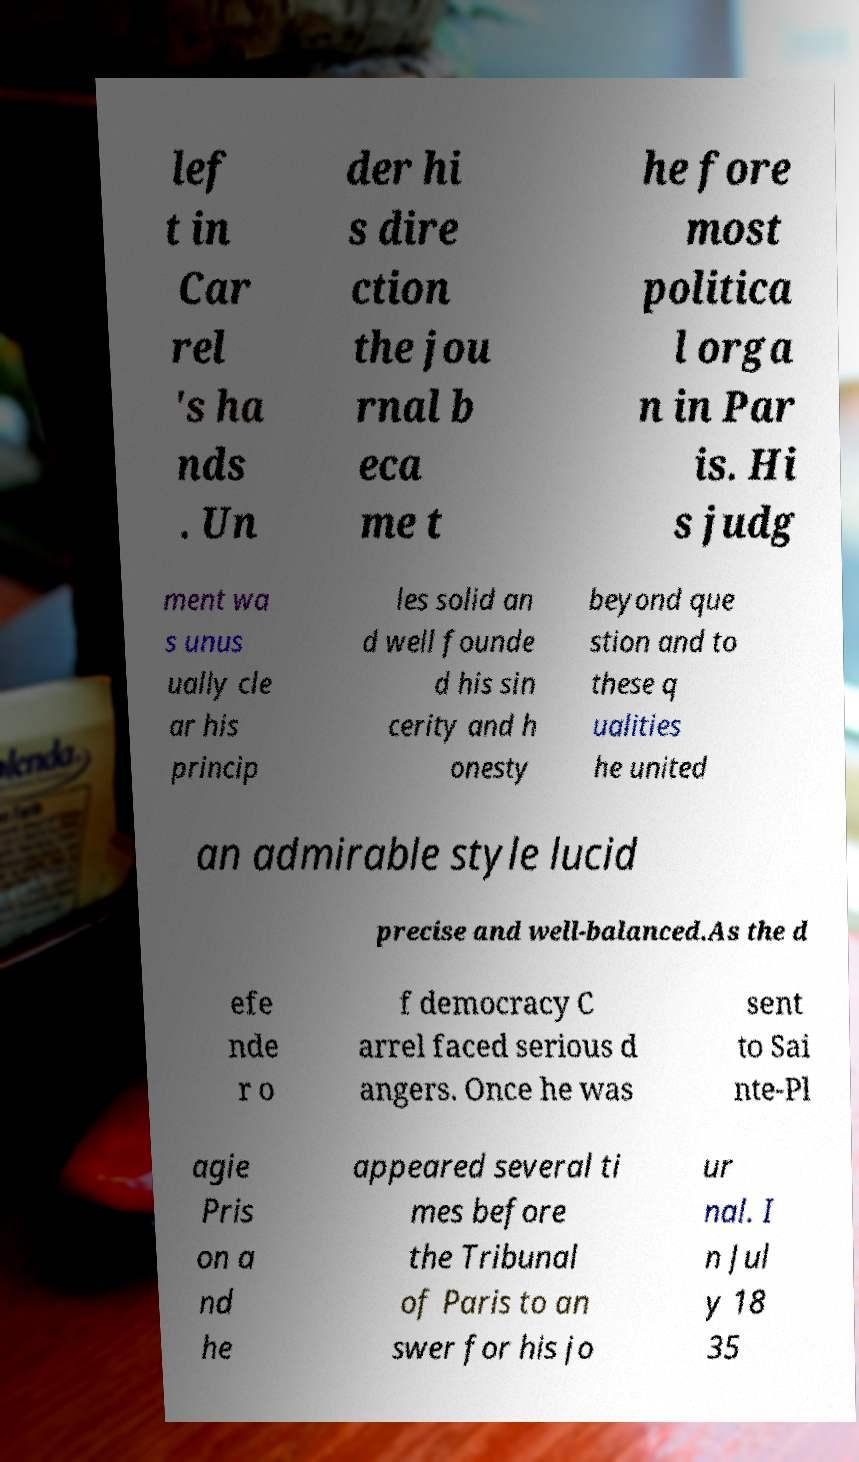Please read and relay the text visible in this image. What does it say? lef t in Car rel 's ha nds . Un der hi s dire ction the jou rnal b eca me t he fore most politica l orga n in Par is. Hi s judg ment wa s unus ually cle ar his princip les solid an d well founde d his sin cerity and h onesty beyond que stion and to these q ualities he united an admirable style lucid precise and well-balanced.As the d efe nde r o f democracy C arrel faced serious d angers. Once he was sent to Sai nte-Pl agie Pris on a nd he appeared several ti mes before the Tribunal of Paris to an swer for his jo ur nal. I n Jul y 18 35 